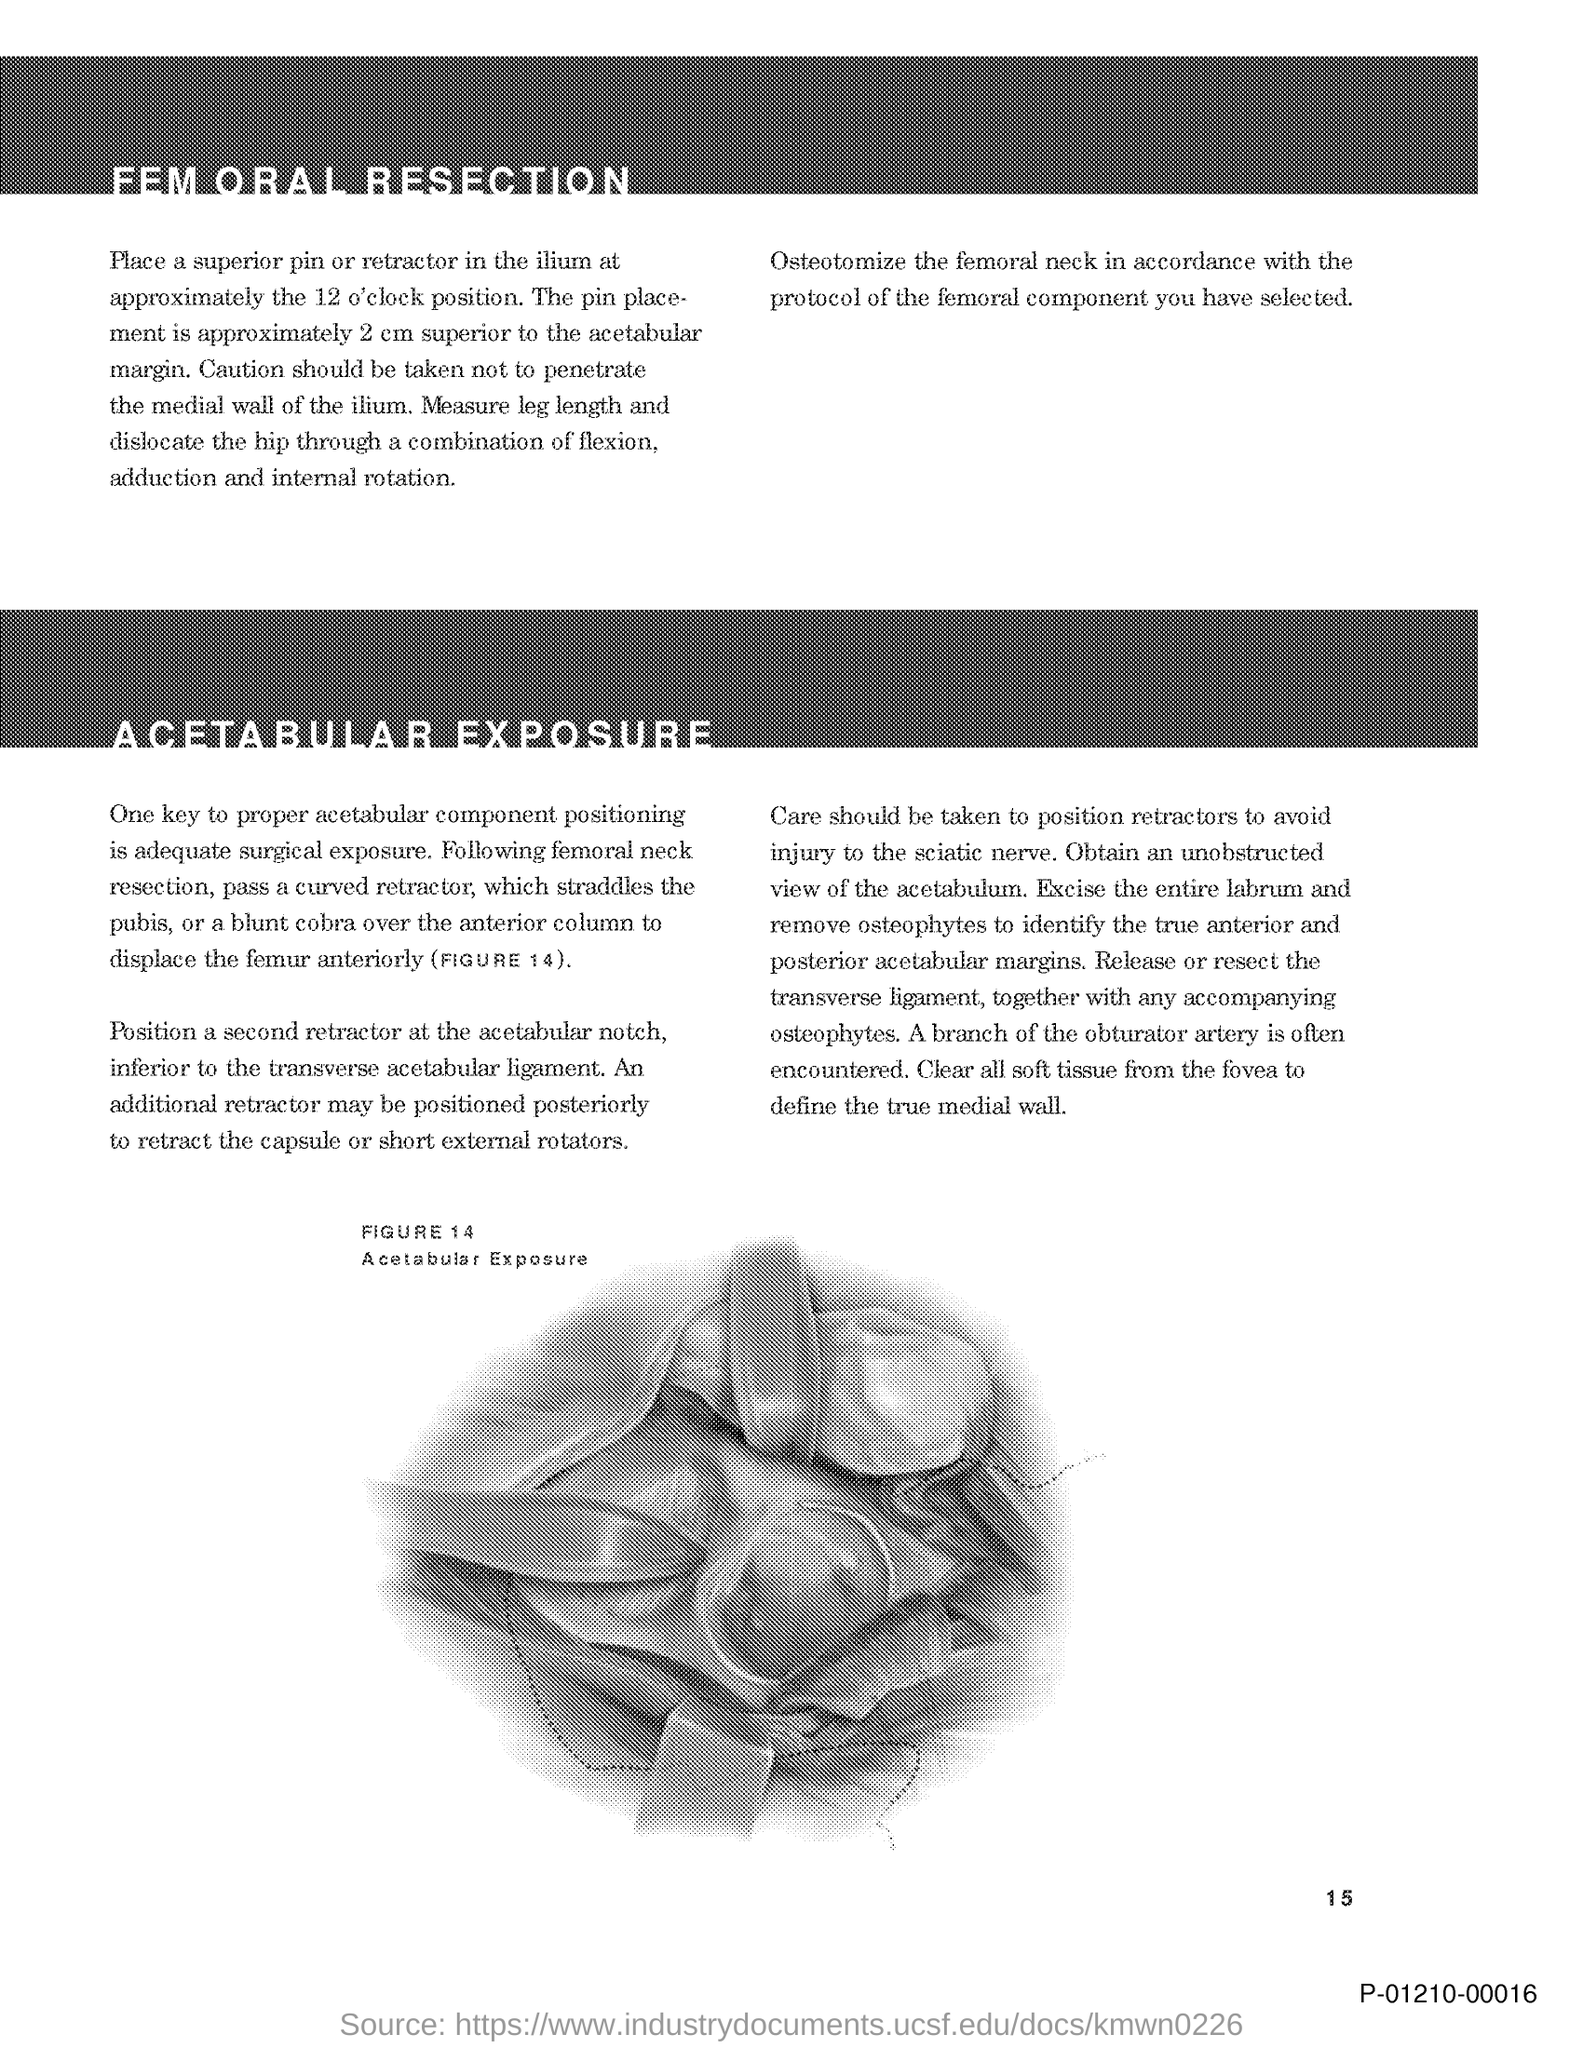Please summarize the main topic discussed on this page. The page seems to detail a surgical procedure for the hip, specifically pertaining to femoral resection and acetabular exposure. 